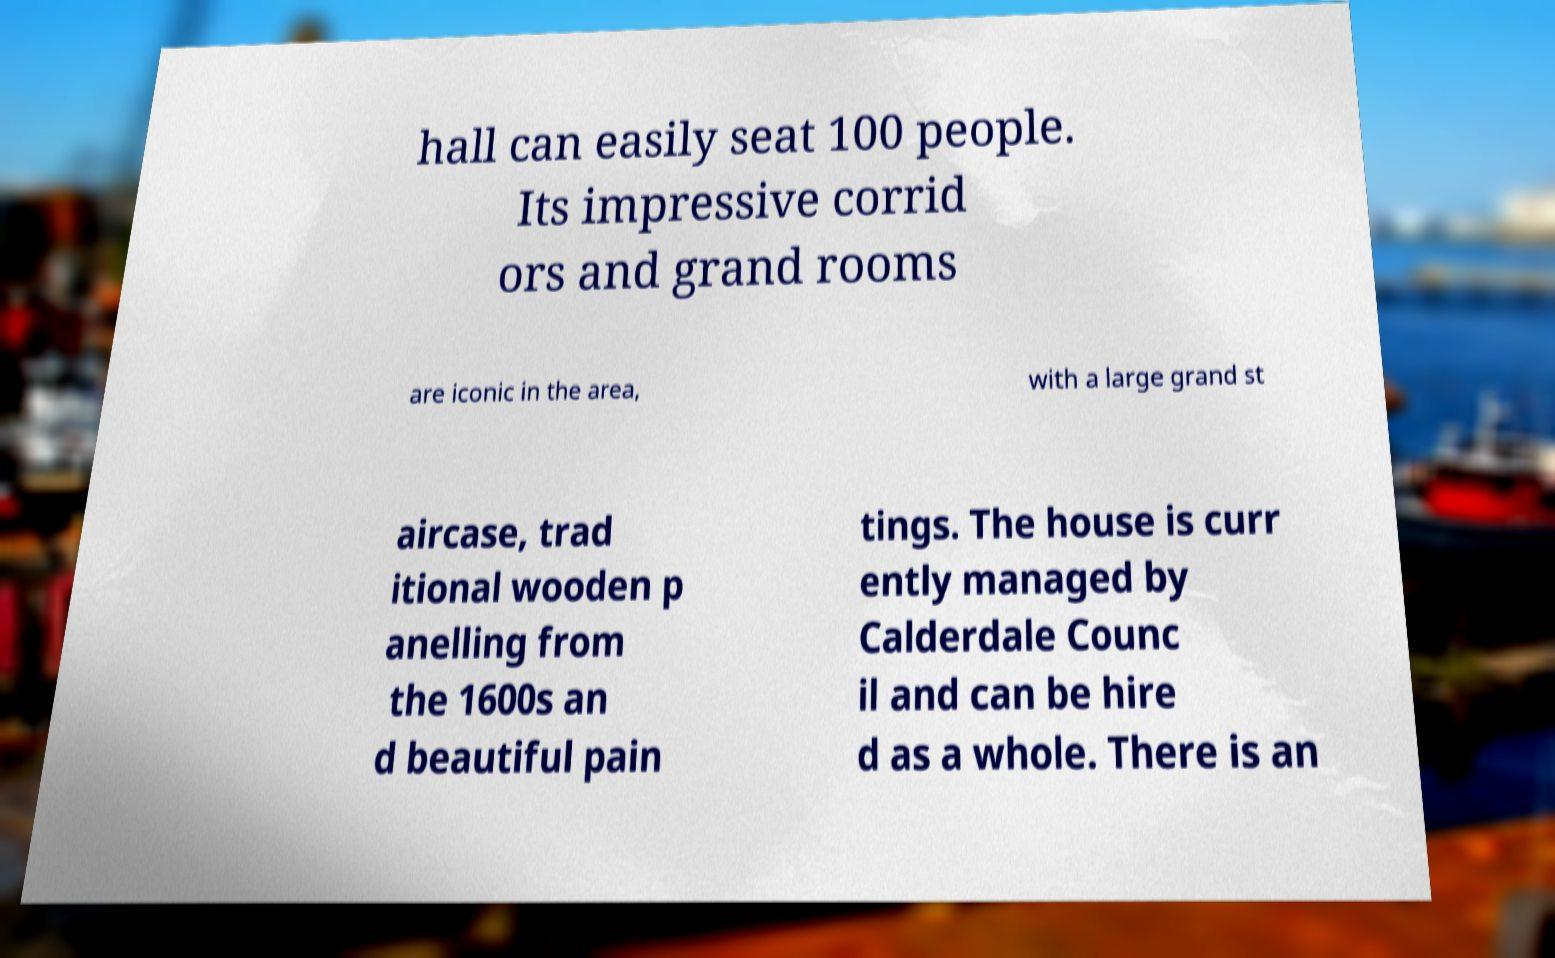Could you extract and type out the text from this image? hall can easily seat 100 people. Its impressive corrid ors and grand rooms are iconic in the area, with a large grand st aircase, trad itional wooden p anelling from the 1600s an d beautiful pain tings. The house is curr ently managed by Calderdale Counc il and can be hire d as a whole. There is an 